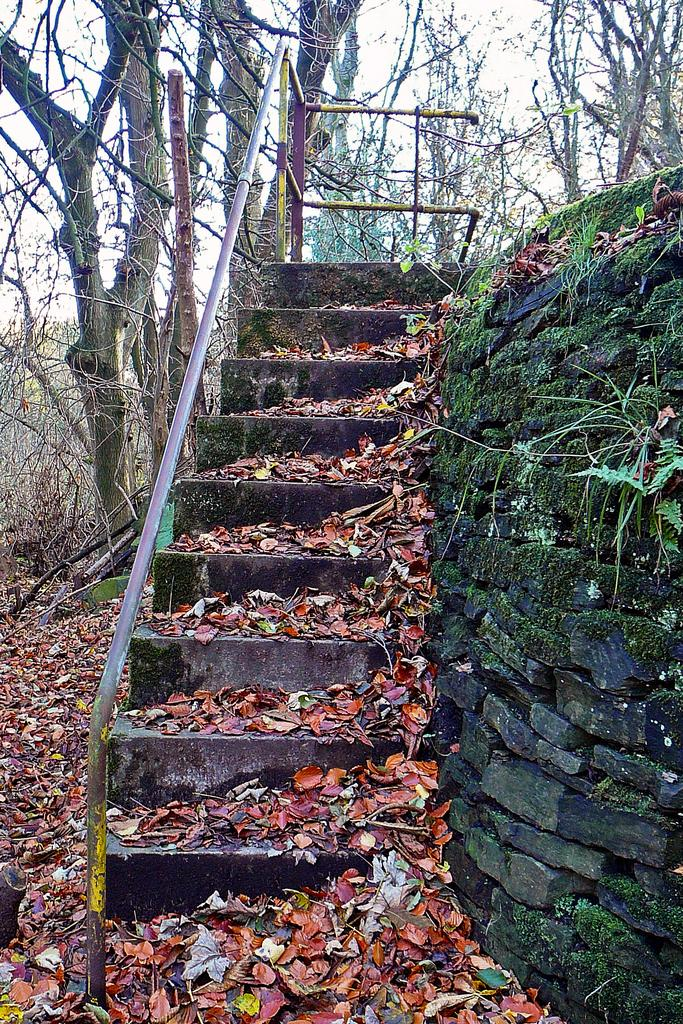What type of structure is present in the image? There is a staircase in the image. What can be seen on the staircase? There are dry leaves on the staircase. What type of natural elements are visible in the image? There are trees visible in the image. What type of architectural feature is present in the image? There is a rock wall in the image. What type of bed is visible in the image? There is no bed present in the image. What type of feast is being prepared on the staircase? There is no feast being prepared in the image; it only shows dry leaves on the staircase. 